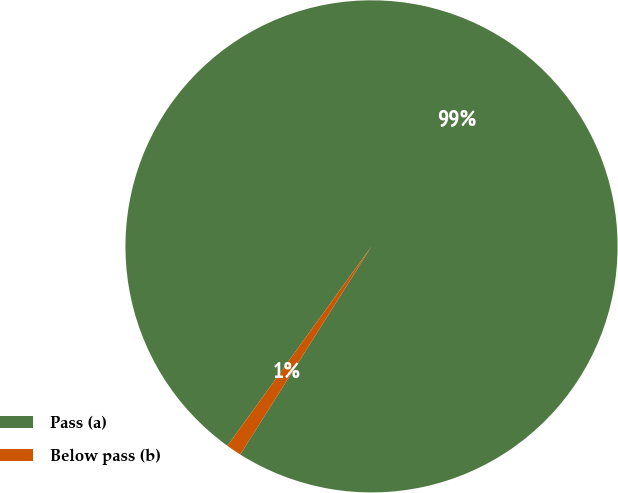Convert chart to OTSL. <chart><loc_0><loc_0><loc_500><loc_500><pie_chart><fcel>Pass (a)<fcel>Below pass (b)<nl><fcel>99.0%<fcel>1.0%<nl></chart> 